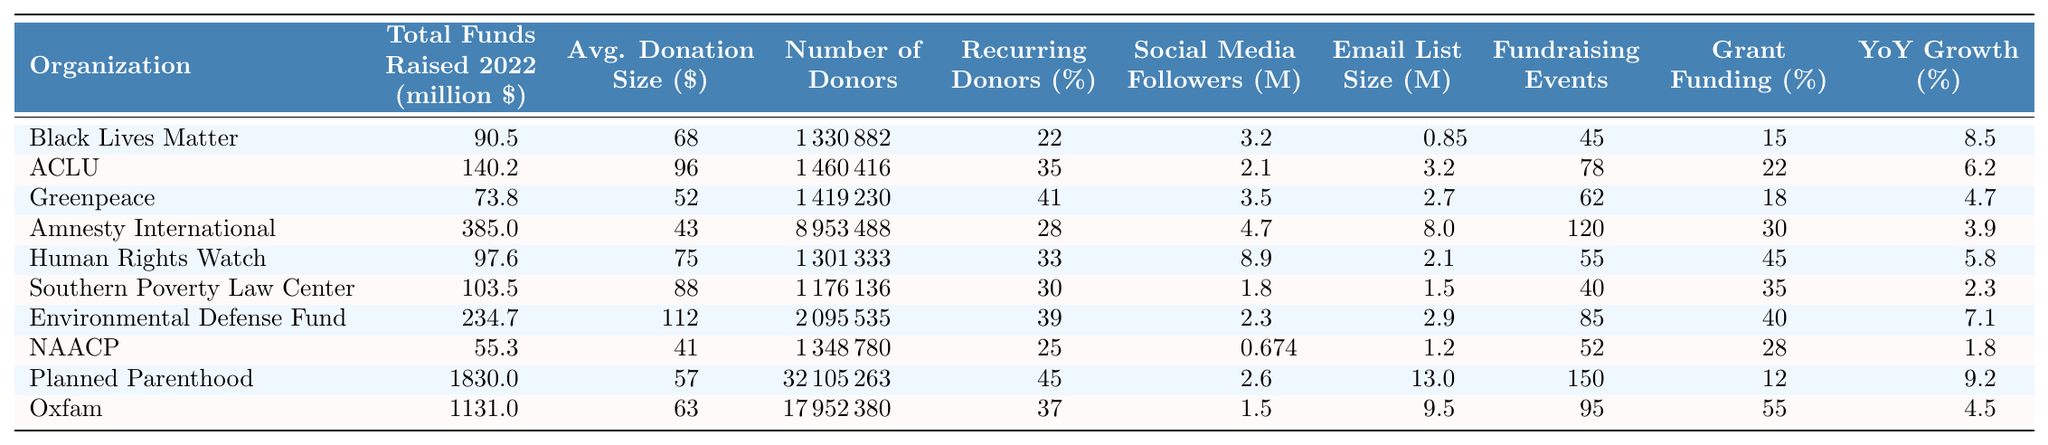What organization raised the most funds in 2022? Looking at the "Total Funds Raised 2022" column, Planned Parenthood raised 1830 million dollars, which is the highest among all organizations listed.
Answer: Planned Parenthood How many donors did Amnesty International have in 2022? Referring to the "Number of Donors" column, Amnesty International had 8,953,488 donors.
Answer: 8953488 What is the average donation size for Greenpeace? The "Average Donation Size" column indicates Greenpeace had an average donation size of 52 dollars.
Answer: 52 Which organization had the highest percentage of recurring donors? By examining the "Recurring Donor Percentage" column, Planned Parenthood had 45% of its donors contributing on a recurring basis, which is the highest percentage.
Answer: Planned Parenthood What is the total funds raised by Oxfam? The "Total Funds Raised 2022" column shows Oxfam raised a total of 1,131 million dollars.
Answer: 1131000 How does the number of social media followers for Human Rights Watch compare to that of Southern Poverty Law Center? Human Rights Watch had 8,900,000 social media followers while Southern Poverty Law Center had 1,800,000 followers. The difference is 8,900,000 - 1,800,000 = 7,100,000, so Human Rights Watch had significantly more followers.
Answer: Human Rights Watch had 7,100,000 more followers What is the average percentage of grant funding across all organizations listed? To find the average, add all percentage values in the "Grant Funding Percentage" column and divide by the number of organizations (10). The total percentage is 15 + 22 + 18 + 30 + 45 + 35 + 40 + 28 + 12 + 55 =  310. The average is 310 / 10 = 31%.
Answer: 31% Is there any organization that raised more than 1 billion dollars in 2022? By checking the "Total Funds Raised 2022" column, both Planned Parenthood (1,830 million) and Oxfam (1,131 million) raised more than 1 billion dollars.
Answer: Yes Which organization had the lowest average donation size? Observing the "Average Donation Size" column, NAACP had the lowest average donation size of 41 dollars.
Answer: NAACP How many more fundraising events were held by Planned Parenthood than by the Southern Poverty Law Center? Planned Parenthood held 150 events, while the Southern Poverty Law Center held 40. The difference is 150 - 40 = 110 events more.
Answer: 110 events What is the year-over-year growth percentage for the Environmental Defense Fund? The "Year over Year Growth" column states Environmental Defense Fund's year-over-year growth is 7.1%.
Answer: 7.1% 